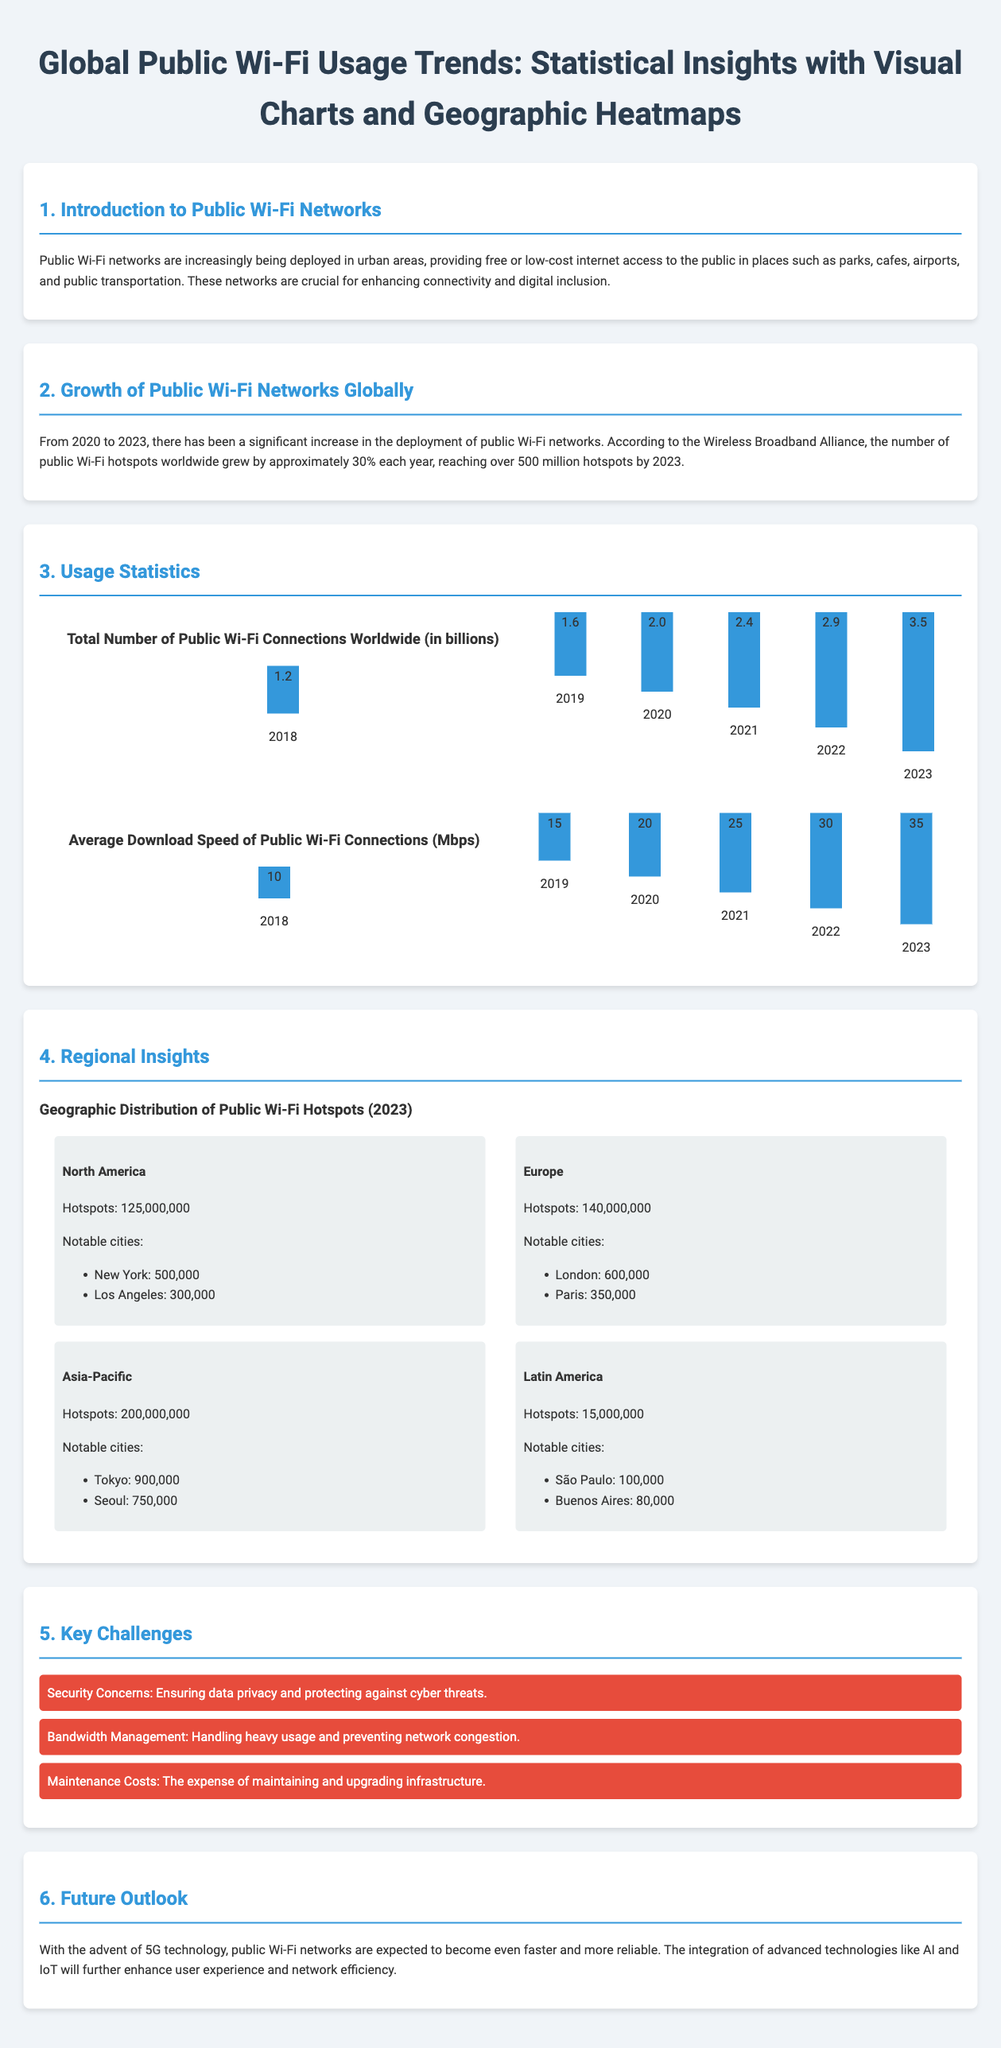What is the growth percentage of public Wi-Fi hotspots per year? The document states that the number of public Wi-Fi hotspots worldwide grew by approximately 30% each year.
Answer: 30% How many public Wi-Fi connections were there worldwide in 2023? The total number of public Wi-Fi connections worldwide is indicated as 3.5 billion in the document.
Answer: 3.5 billion What is the average download speed of public Wi-Fi connections in 2023? The average download speed of public Wi-Fi connections is mentioned as 35 Mbps for 2023.
Answer: 35 Mbps Which region has the highest number of public Wi-Fi hotspots? The document lists the Asia-Pacific region with 200 million hotspots as having the highest number.
Answer: Asia-Pacific What are notable cities in North America with public Wi-Fi hotspots? The notable cities listed in North America are New York and Los Angeles.
Answer: New York, Los Angeles What is one key challenge mentioned regarding public Wi-Fi networks? The document highlights security concerns as a key challenge for public Wi-Fi networks.
Answer: Security concerns How many public Wi-Fi hotspots are there in Europe? According to the document, Europe has 140 million public Wi-Fi hotspots.
Answer: 140 million What notable technology is expected to enhance public Wi-Fi networks in the future? The future outlook mentions the advent of 5G technology as an enhancing factor for public Wi-Fi networks.
Answer: 5G technology 